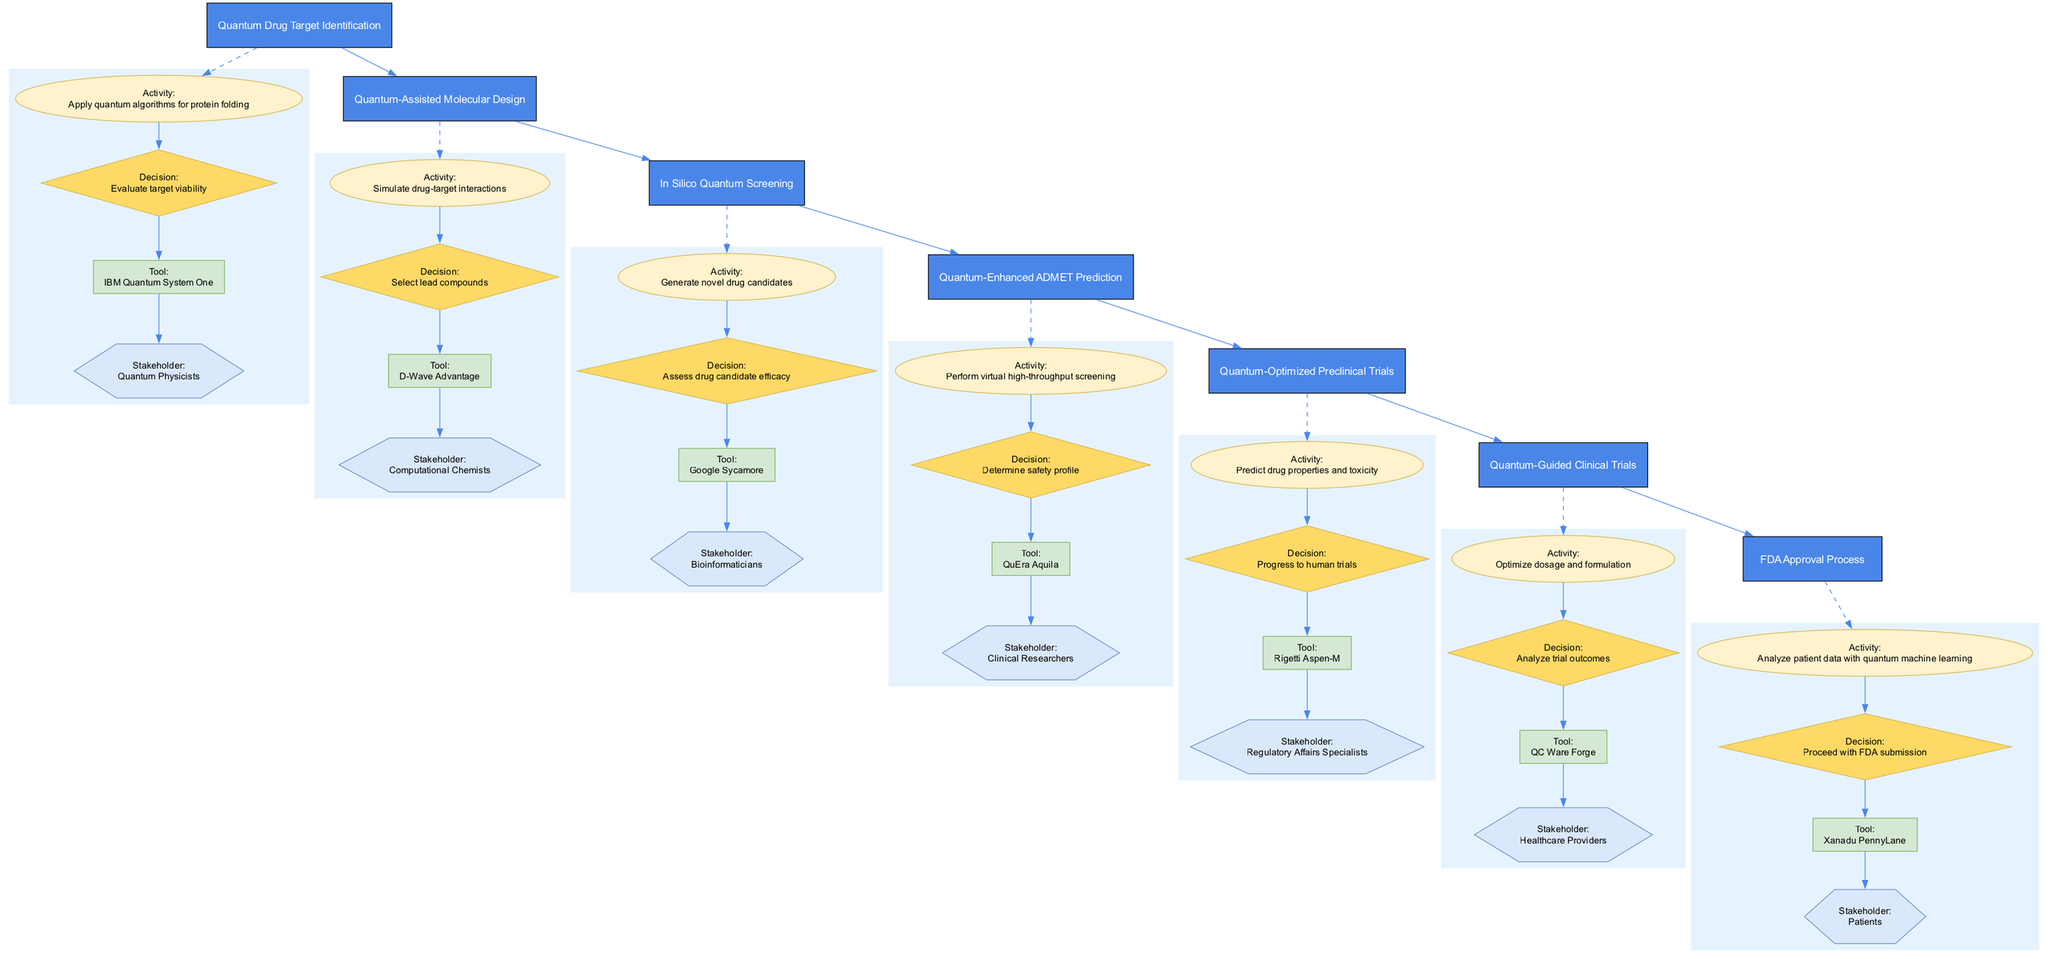What is the first stage in the clinical pathway? The first stage listed in the pathway is "Quantum Drug Target Identification," which is the starting point of the drug discovery process highlighted in the diagram.
Answer: Quantum Drug Target Identification How many decision points are there in the pathway? By counting the distinct decision nodes outlined in the diagram, we see there are seven decision points involved in the clinical pathway.
Answer: 7 Which tool is used in the activity of "Simulate drug-target interactions"? The diagram links the activity of "Simulate drug-target interactions" to the tool "D-Wave Advantage," indicating that this tool is utilized for that specific activity.
Answer: D-Wave Advantage What is evaluated at the "Evaluate target viability" decision point? At the "Evaluate target viability" decision point, stakeholders assess whether the identified drug targets are suitable and viable for further development in the pathway.
Answer: Target viability Which stakeholders are involved in the "Quantum-Guided Clinical Trials" stage? The stakeholders that participate in the "Quantum-Guided Clinical Trials" stage include "Clinical Researchers," who are essential for conducting and overseeing the trials at this point of the pathway.
Answer: Clinical Researchers What comes after "Predict drug properties and toxicity"? Following the "Predict drug properties and toxicity" decision point, the next step in the pathway is to "Optimize dosage and formulation," indicating the progression of activities after toxicity prediction.
Answer: Optimize dosage and formulation What stage is before "FDA Approval Process"? The stage that precedes the "FDA Approval Process" is "Quantum-Guided Clinical Trials," showing the sequential order of steps leading up to the final regulatory approval.
Answer: Quantum-Guided Clinical Trials How is "Quantum-Enhanced ADMET Prediction" related to drug testing? "Quantum-Enhanced ADMET Prediction" acts as a crucial intermediate step, providing predictions regarding absorption, distribution, metabolism, excretion, and toxicity, which informs further drug testing phases in development.
Answer: Informing drug testing What stage involves the use of "IBM Quantum System One"? The "IBM Quantum System One" is utilized during the "Quantum-Assisted Molecular Design" stage, linking specific tools to particular phases in the clinical pathway.
Answer: Quantum-Assisted Molecular Design 